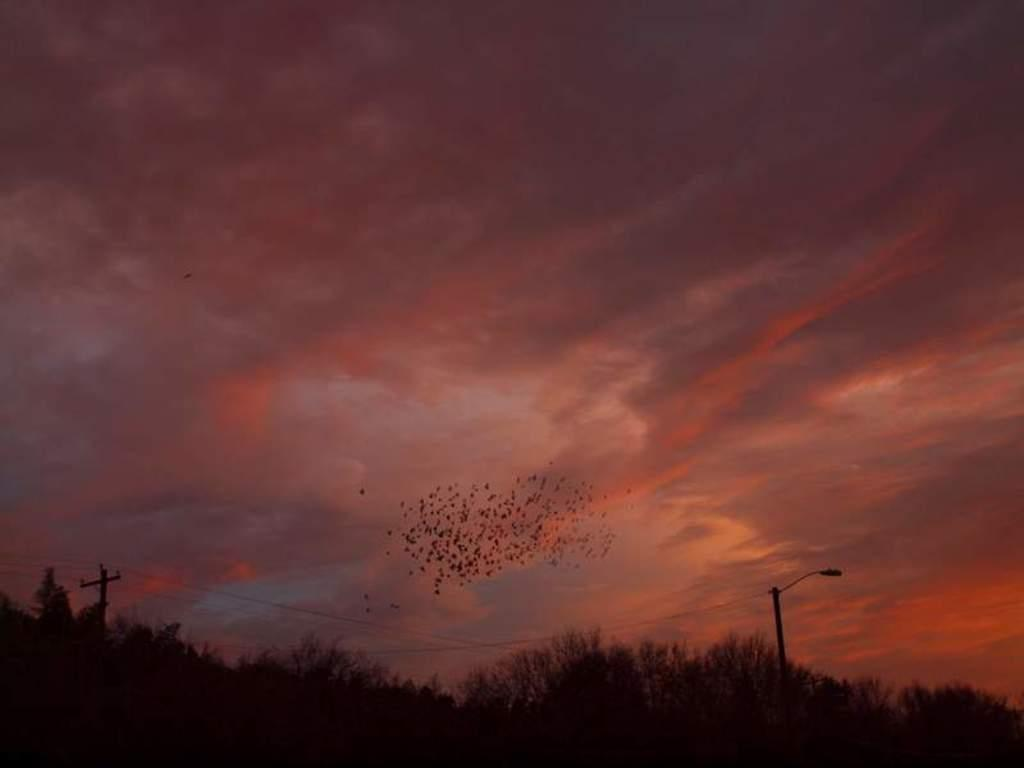What can be seen at the bottom of the image? There are trees and poles at the bottom of the image. What is located in the middle of the image? There are objects in the sky in the middle of the image. What else is present in the sky? There are clouds in the sky. How many babies are crawling on the trees in the image? There are no babies present in the image; it features trees and poles at the bottom and objects in the sky in the middle. What type of plantation can be seen in the image? There is no plantation present in the image. 